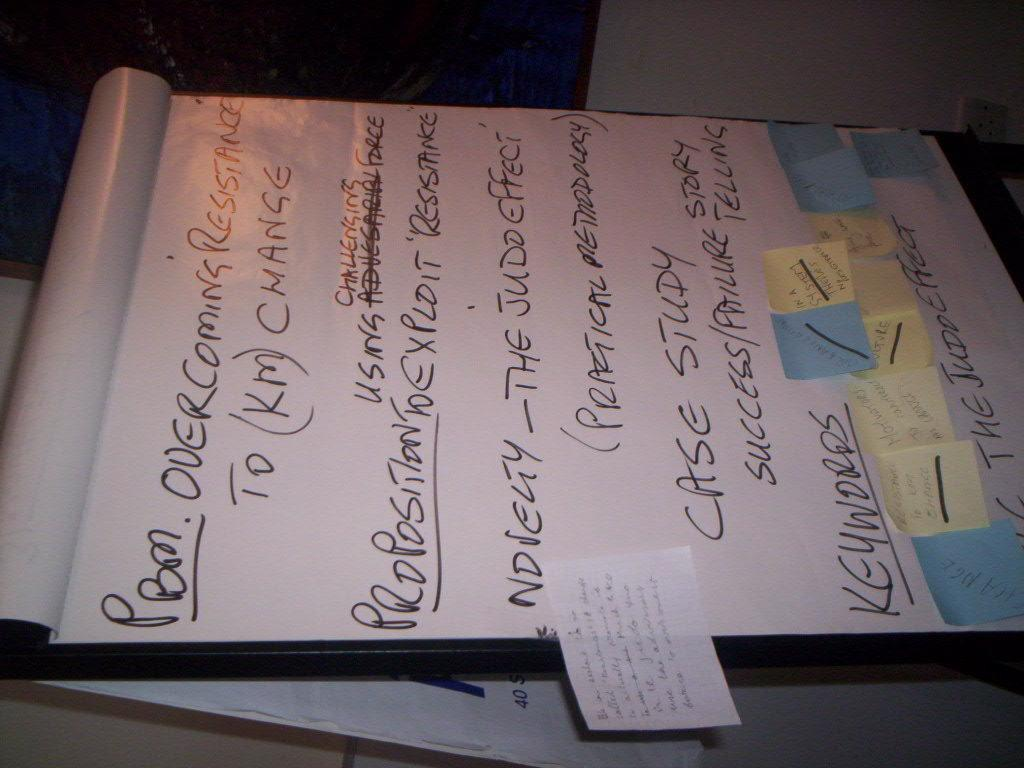<image>
Summarize the visual content of the image. A notepad has hand written text that says Overcoming Resistance. 